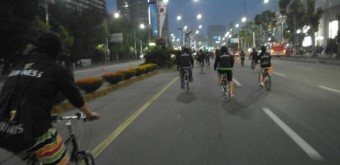What time of day does it seem to be in this image? The image appears to be captured during the evening hours, as suggested by the artificial lighting from the streetlamps and the darkness of the sky. 